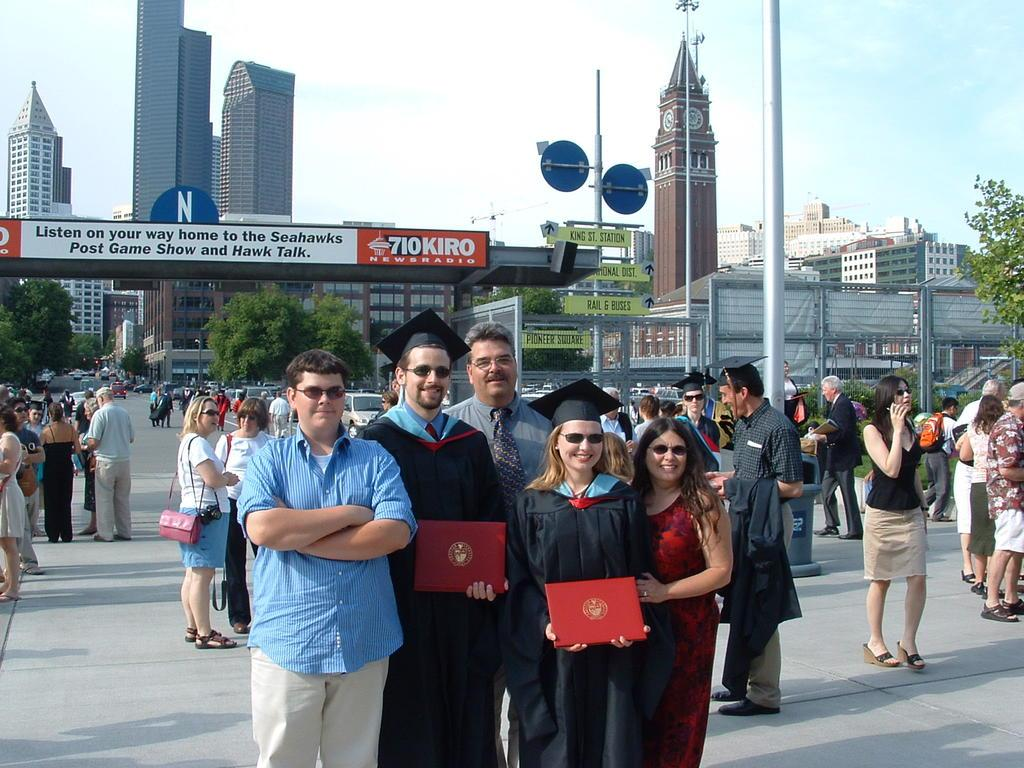<image>
Create a compact narrative representing the image presented. Some people are posing for a picture with a banner from Newsradio at the background. 